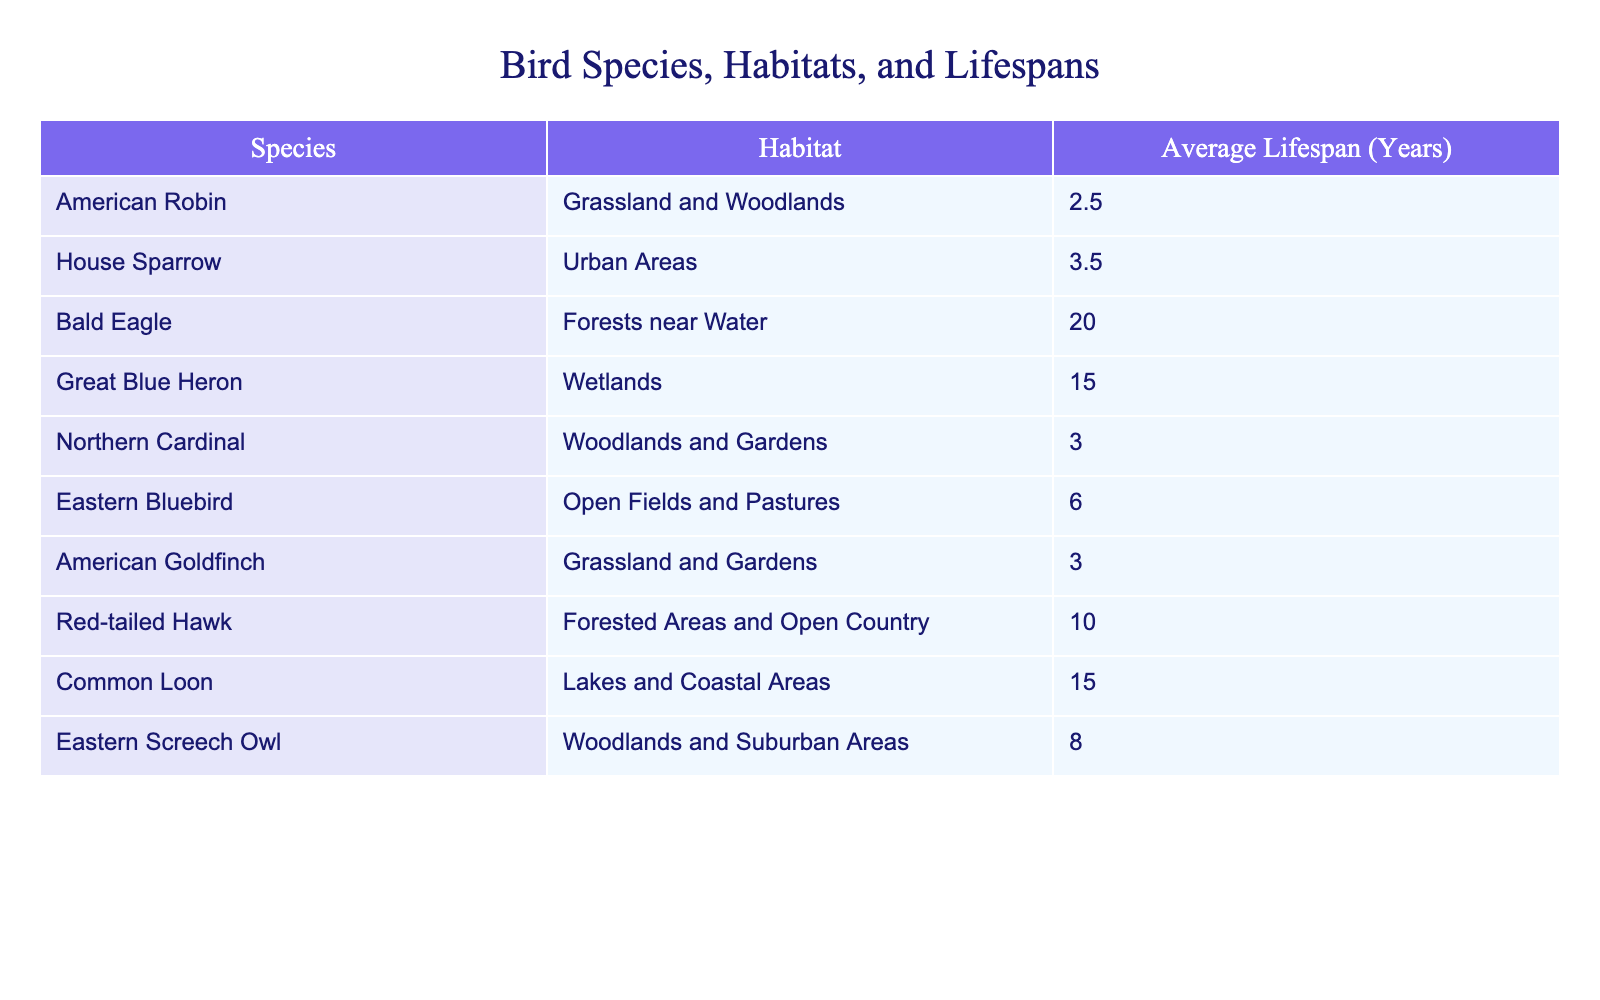What is the average lifespan of the American Robin? The table states that the average lifespan of the American Robin is 2.5 years. This information can be directly retrieved from the column labeled "Average Lifespan (Years)."
Answer: 2.5 Which bird has the longest lifespan, and what is it? By reviewing the "Average Lifespan (Years)" column, we see that the Bald Eagle has the longest lifespan, which is 20 years. This is confirmed by comparing the lifespan values across all species.
Answer: Bald Eagle, 20 Is the average lifespan of a House Sparrow greater than 4 years? The lifespan of the House Sparrow is listed as 3.5 years. Thus, it is less than 4 years. This is answered by simply referencing the corresponding lifespan value in the table.
Answer: No What is the difference in average lifespan between the Great Blue Heron and the Eastern Bluebird? The Great Blue Heron has an average lifespan of 15 years, while the Eastern Bluebird has an average lifespan of 6 years. To find the difference, we subtract: 15 - 6 = 9 years.
Answer: 9 years How many bird species have an average lifespan of over 10 years? To answer this, we need to count the species with a lifespan of over 10 years listed in the "Average Lifespan (Years)" column. The Bald Eagle (20), Great Blue Heron (15), Common Loon (15), and Red-tailed Hawk (10) result in 4 species counted. However, only Bald Eagle and Great Blue Heron are over 10 years.
Answer: 2 species Which bird species is observed in urban areas, and what is its lifespan? The table shows the House Sparrow is the species observed in urban areas, with an average lifespan of 3.5 years. This can be found by locating the corresponding row for urban habitats and reading off the lifespan.
Answer: House Sparrow, 3.5 What's the overall average lifespan of the birds listed in the table? To find the overall average lifespan, we first sum all the lifespans: (2.5 + 3.5 + 20 + 15 + 3 + 6 + 3 + 10 + 15 + 8) = 86 years. There are 10 species, so we divide by 10 to get the average: 86/10 = 8.6 years.
Answer: 8.6 years Does the table indicate that the Eastern Screech Owl lives longer than the American Goldfinch? The Eastern Screech Owl has an average lifespan of 8 years, while the American Goldfinch has a lifespan of 3 years. Since 8 is greater than 3, this is true as indicated by the corresponding values in the table.
Answer: Yes Which habitat is associated with the Red-tailed Hawk, and does it have a lifespan greater than 8 years? The Red-tailed Hawk is observed in forested areas and open country, with an average lifespan of 10 years. Since 10 is greater than 8, both the habitat and lifespan can be verified from the table.
Answer: Yes, Forested Areas and Open Country, 10 years 